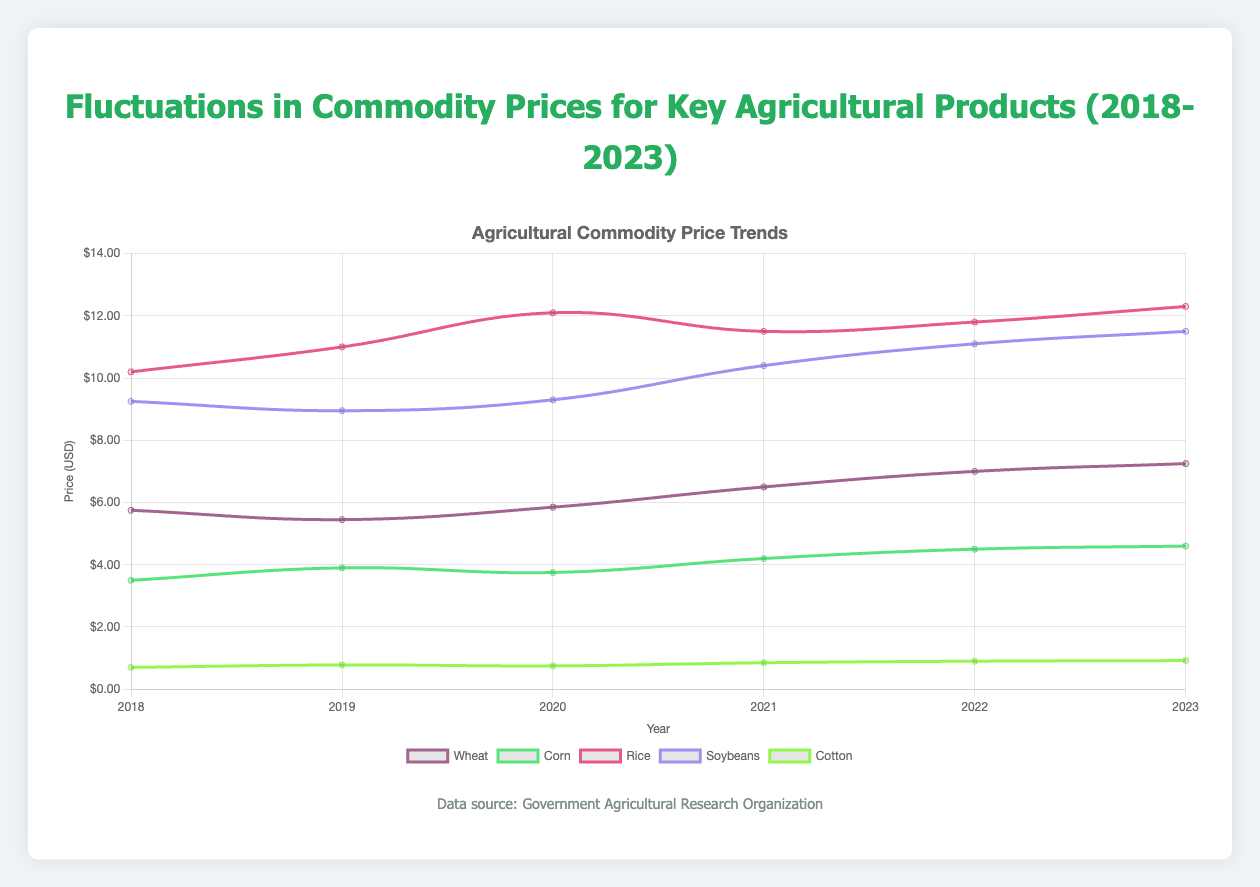What's the trend in the price of Wheat from 2018 to 2023? Starting at $5.75 in 2018, Wheat prices exhibit a general upward trend, increasing each year and reaching $7.25 in 2023.
Answer: Steady increase Which commodity experienced the highest price increase from 2018 to 2023 and how much was the increase? The price of Rice increased from $10.20 in 2018 to $12.30 in 2023. Calculate the difference: $12.30 - $10.20 = $2.10.
Answer: Rice, $2.10 How did the price of Soybeans change from 2018 to 2019 and what was the percentage change? Soybeans dropped from $9.25 in 2018 to $8.95 in 2019. Calculate the difference: $9.25 - $8.95 = $0.30. Then calculate the percentage: ($0.30 / $9.25) * 100 ≈ 3.24%.
Answer: Decreased by approximately 3.24% In which year was the price of Cotton the highest, and what was the price? The price of Cotton was highest in 2023 at $0.92.
Answer: 2023, $0.92 Compare the price trends of Corn and Soybeans from 2018 to 2023. Both Corn and Soybeans generally increased from 2018 to 2023. Corn increased from $3.50 to $4.60, whereas Soybeans increased from $9.25 to $11.50. However, Soybeans show more variability compared to the steady rise of Corn.
Answer: Both increased, but Soybeans show more variability Which commodity had the least fluctuation in price over the years, and what were its minimum and maximum prices? Cotton showed the least fluctuation. Its price fluctuated between $0.70 (2018) and $0.92 (2023).
Answer: Cotton, min $0.70, max $0.92 What was the average price of Rice over the period 2018 to 2023? Add the yearly prices: $10.20 + $11.00 + $12.10 + $11.50 + $11.80 + $12.30 = $68.90. Then divide by the number of years: $68.90 / 6 = $11.48.
Answer: $11.48 Did the prices of any of the commodities decrease in any year? If so, name them and the respective years. Wheat decreased from 2018 ($5.75) to 2019 ($5.45), Corn decreased from 2019 ($3.90) to 2020 ($3.75), and Soybeans decreased from 2018 ($9.25) to 2019 ($8.95).
Answer: Wheat (2019), Corn (2020), Soybeans (2019) Compare the prices of Wheat and Rice in 2018 and determine the difference. Wheat was $5.75 and Rice was $10.20 in 2018. The difference is $10.20 - $5.75 = $4.45.
Answer: $4.45 